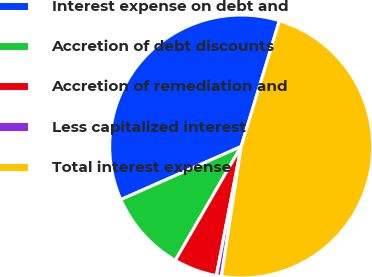Convert chart to OTSL. <chart><loc_0><loc_0><loc_500><loc_500><pie_chart><fcel>Interest expense on debt and<fcel>Accretion of debt discounts<fcel>Accretion of remediation and<fcel>Less capitalized interest<fcel>Total interest expense<nl><fcel>36.3%<fcel>10.04%<fcel>5.33%<fcel>0.62%<fcel>47.7%<nl></chart> 